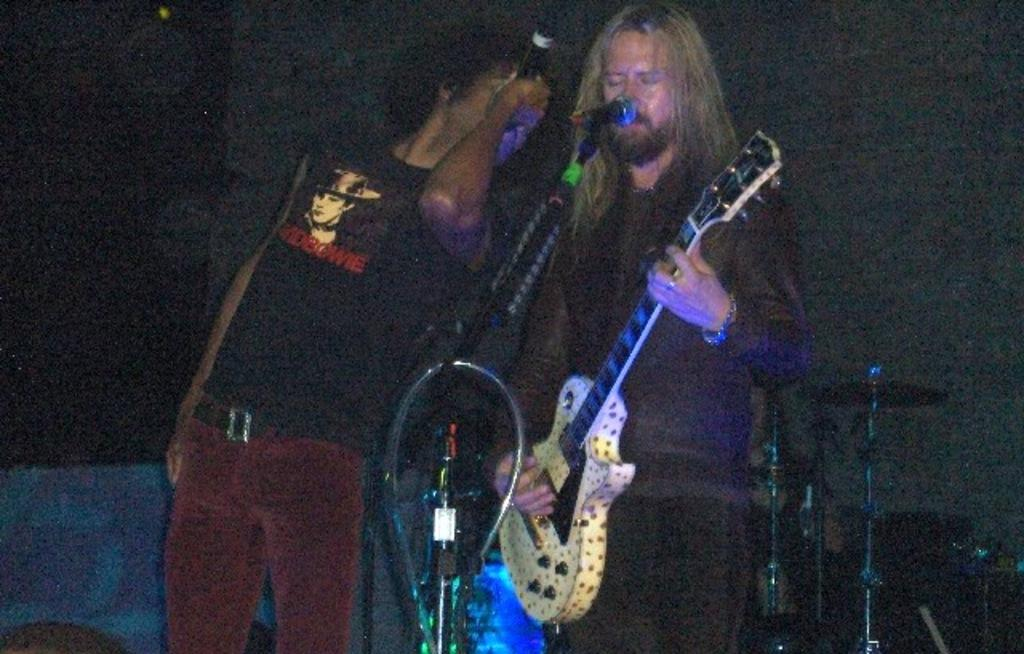How many people are in the image? There are two persons in the image. What is the person on the left holding in his hand? The person on the left is holding a microphone in his hand. What is the person on the right holding in his hand? The person on the right is holding a guitar in his hand. What is the tendency of the square in the image? There is no square present in the image, so it is not possible to determine any tendencies. 